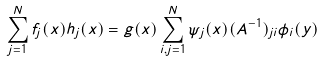<formula> <loc_0><loc_0><loc_500><loc_500>\sum _ { j = 1 } ^ { N } f _ { j } ( x ) h _ { j } ( x ) = g ( x ) \sum _ { i , j = 1 } ^ { N } \psi _ { j } ( x ) ( A ^ { - 1 } ) _ { j i } \phi _ { i } ( y )</formula> 